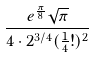Convert formula to latex. <formula><loc_0><loc_0><loc_500><loc_500>\frac { e ^ { \frac { \pi } { 8 } } \sqrt { \pi } } { 4 \cdot 2 ^ { 3 / 4 } ( \frac { 1 } { 4 } ! ) ^ { 2 } }</formula> 